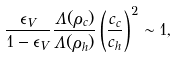Convert formula to latex. <formula><loc_0><loc_0><loc_500><loc_500>\frac { \epsilon _ { V } } { 1 - \epsilon _ { V } } \frac { \Lambda ( \rho _ { c } ) } { \Lambda ( \rho _ { h } ) } \left ( \frac { c _ { c } } { c _ { h } } \right ) ^ { 2 } \sim 1 ,</formula> 